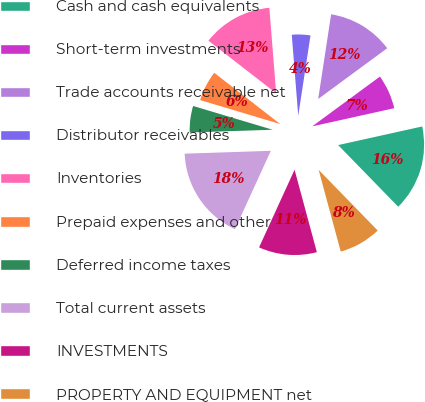<chart> <loc_0><loc_0><loc_500><loc_500><pie_chart><fcel>Cash and cash equivalents<fcel>Short-term investments<fcel>Trade accounts receivable net<fcel>Distributor receivables<fcel>Inventories<fcel>Prepaid expenses and other<fcel>Deferred income taxes<fcel>Total current assets<fcel>INVESTMENTS<fcel>PROPERTY AND EQUIPMENT net<nl><fcel>16.18%<fcel>6.62%<fcel>12.5%<fcel>3.68%<fcel>13.23%<fcel>5.88%<fcel>5.15%<fcel>17.65%<fcel>11.03%<fcel>8.09%<nl></chart> 